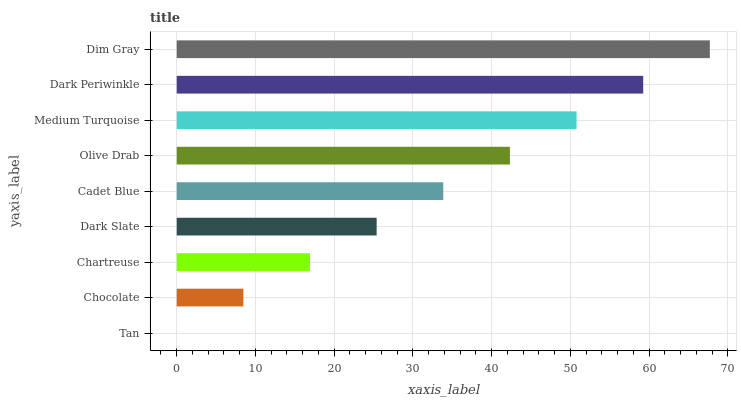Is Tan the minimum?
Answer yes or no. Yes. Is Dim Gray the maximum?
Answer yes or no. Yes. Is Chocolate the minimum?
Answer yes or no. No. Is Chocolate the maximum?
Answer yes or no. No. Is Chocolate greater than Tan?
Answer yes or no. Yes. Is Tan less than Chocolate?
Answer yes or no. Yes. Is Tan greater than Chocolate?
Answer yes or no. No. Is Chocolate less than Tan?
Answer yes or no. No. Is Cadet Blue the high median?
Answer yes or no. Yes. Is Cadet Blue the low median?
Answer yes or no. Yes. Is Tan the high median?
Answer yes or no. No. Is Olive Drab the low median?
Answer yes or no. No. 